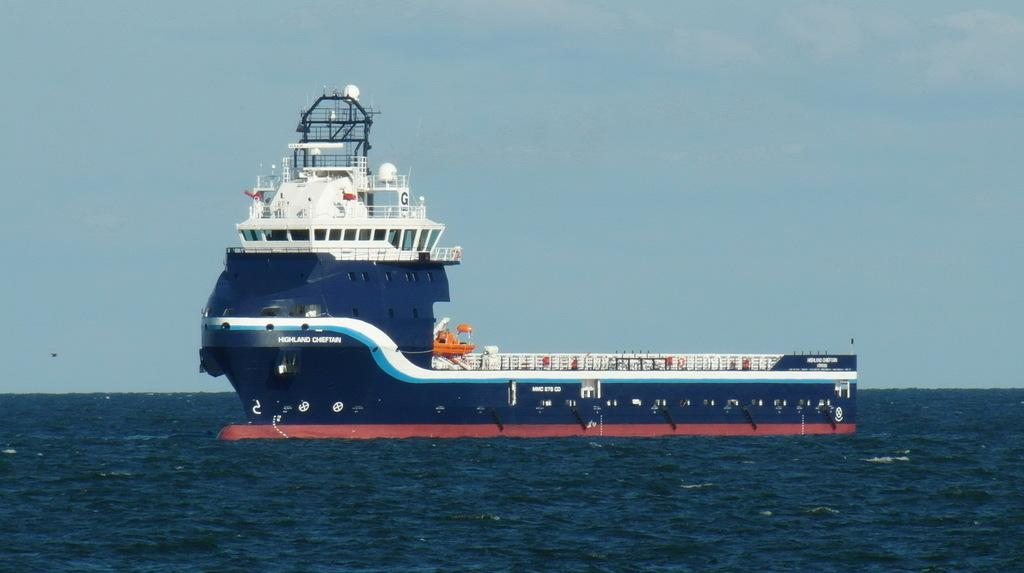What is the main subject of the image? The main subject of the image is a ship. Where is the ship located in the image? The ship is on the water surface in the image. What colors can be seen on the ship? The ship has blue and white colors. What is the color of the sky in the image? The sky is blue in the image. What type of vase is placed on the ship's deck in the image? There is no vase present on the ship's deck in the image. 